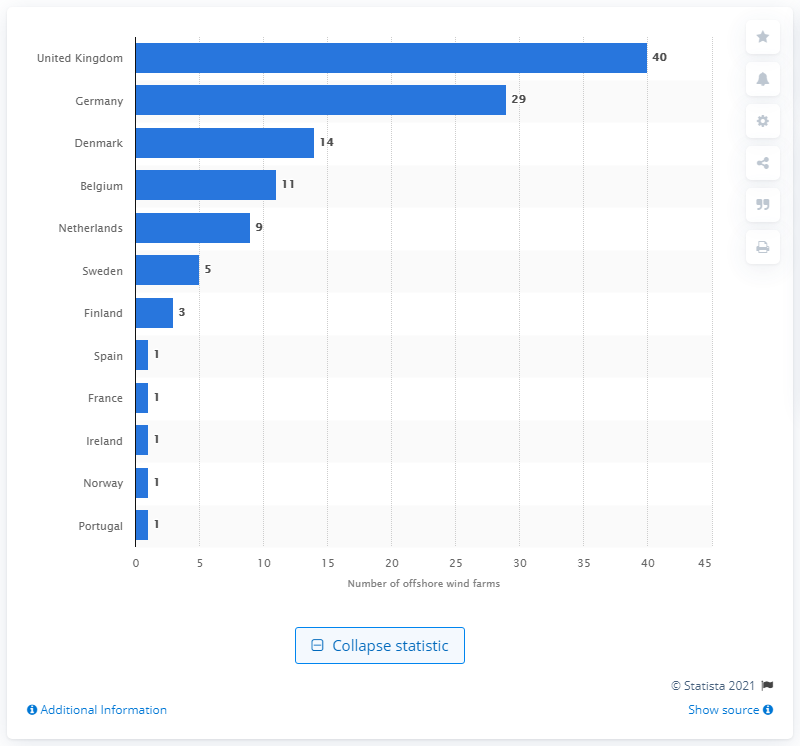Mention a couple of crucial points in this snapshot. The United Kingdom operates 40 offshore wind farms. In 2019, Portugal became the first country to connect its first offshore wind turbine. 